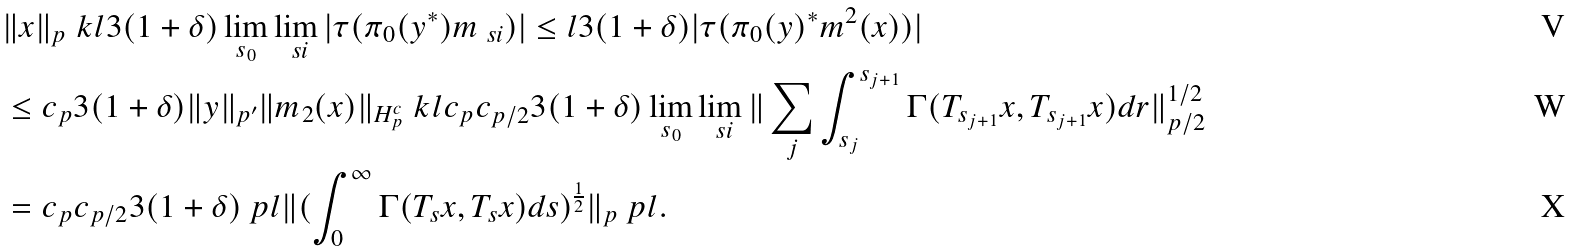Convert formula to latex. <formula><loc_0><loc_0><loc_500><loc_500>& \| x \| _ { p } \ k l 3 ( 1 + \delta ) \lim _ { s _ { 0 } } \lim _ { \ s i } | \tau ( \pi _ { 0 } ( y ^ { * } ) m _ { \ s i } ) | \leq l 3 ( 1 + \delta ) | \tau ( \pi _ { 0 } ( y ) ^ { * } m ^ { 2 } ( x ) ) | \\ & \leq c _ { p } 3 ( 1 + \delta ) \| y \| _ { p ^ { \prime } } \| m _ { 2 } ( x ) \| _ { H _ { p } ^ { c } } \ k l c _ { p } c _ { p / 2 } 3 ( 1 + \delta ) \lim _ { s _ { 0 } } \lim _ { \ s i } \| \sum _ { j } \int _ { s _ { j } } ^ { s _ { j + 1 } } \Gamma ( T _ { s _ { j + 1 } } x , T _ { s _ { j + 1 } } x ) d r \| _ { p / 2 } ^ { 1 / 2 } \\ & = c _ { p } c _ { p / 2 } 3 ( 1 + \delta ) \ p l \| ( \int _ { 0 } ^ { \infty } \Gamma ( T _ { s } x , T _ { s } x ) d s ) ^ { \frac { 1 } { 2 } } \| _ { p } \ p l .</formula> 